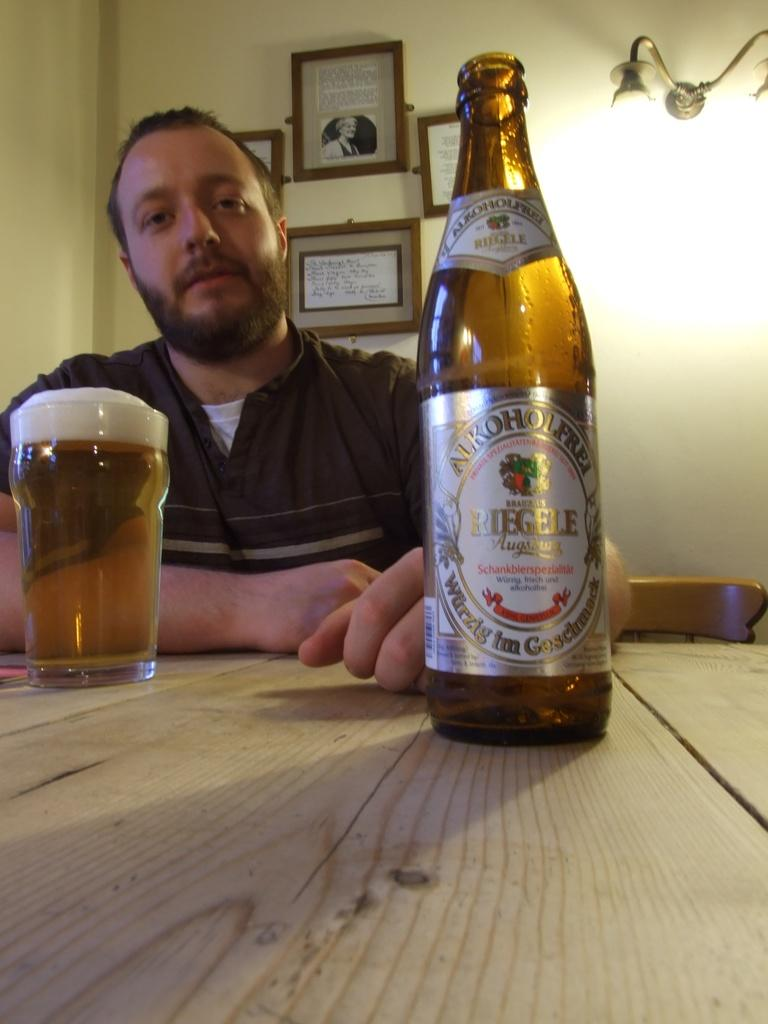<image>
Present a compact description of the photo's key features. a man in front of a glass and bottle of Alkohol Frei ale 